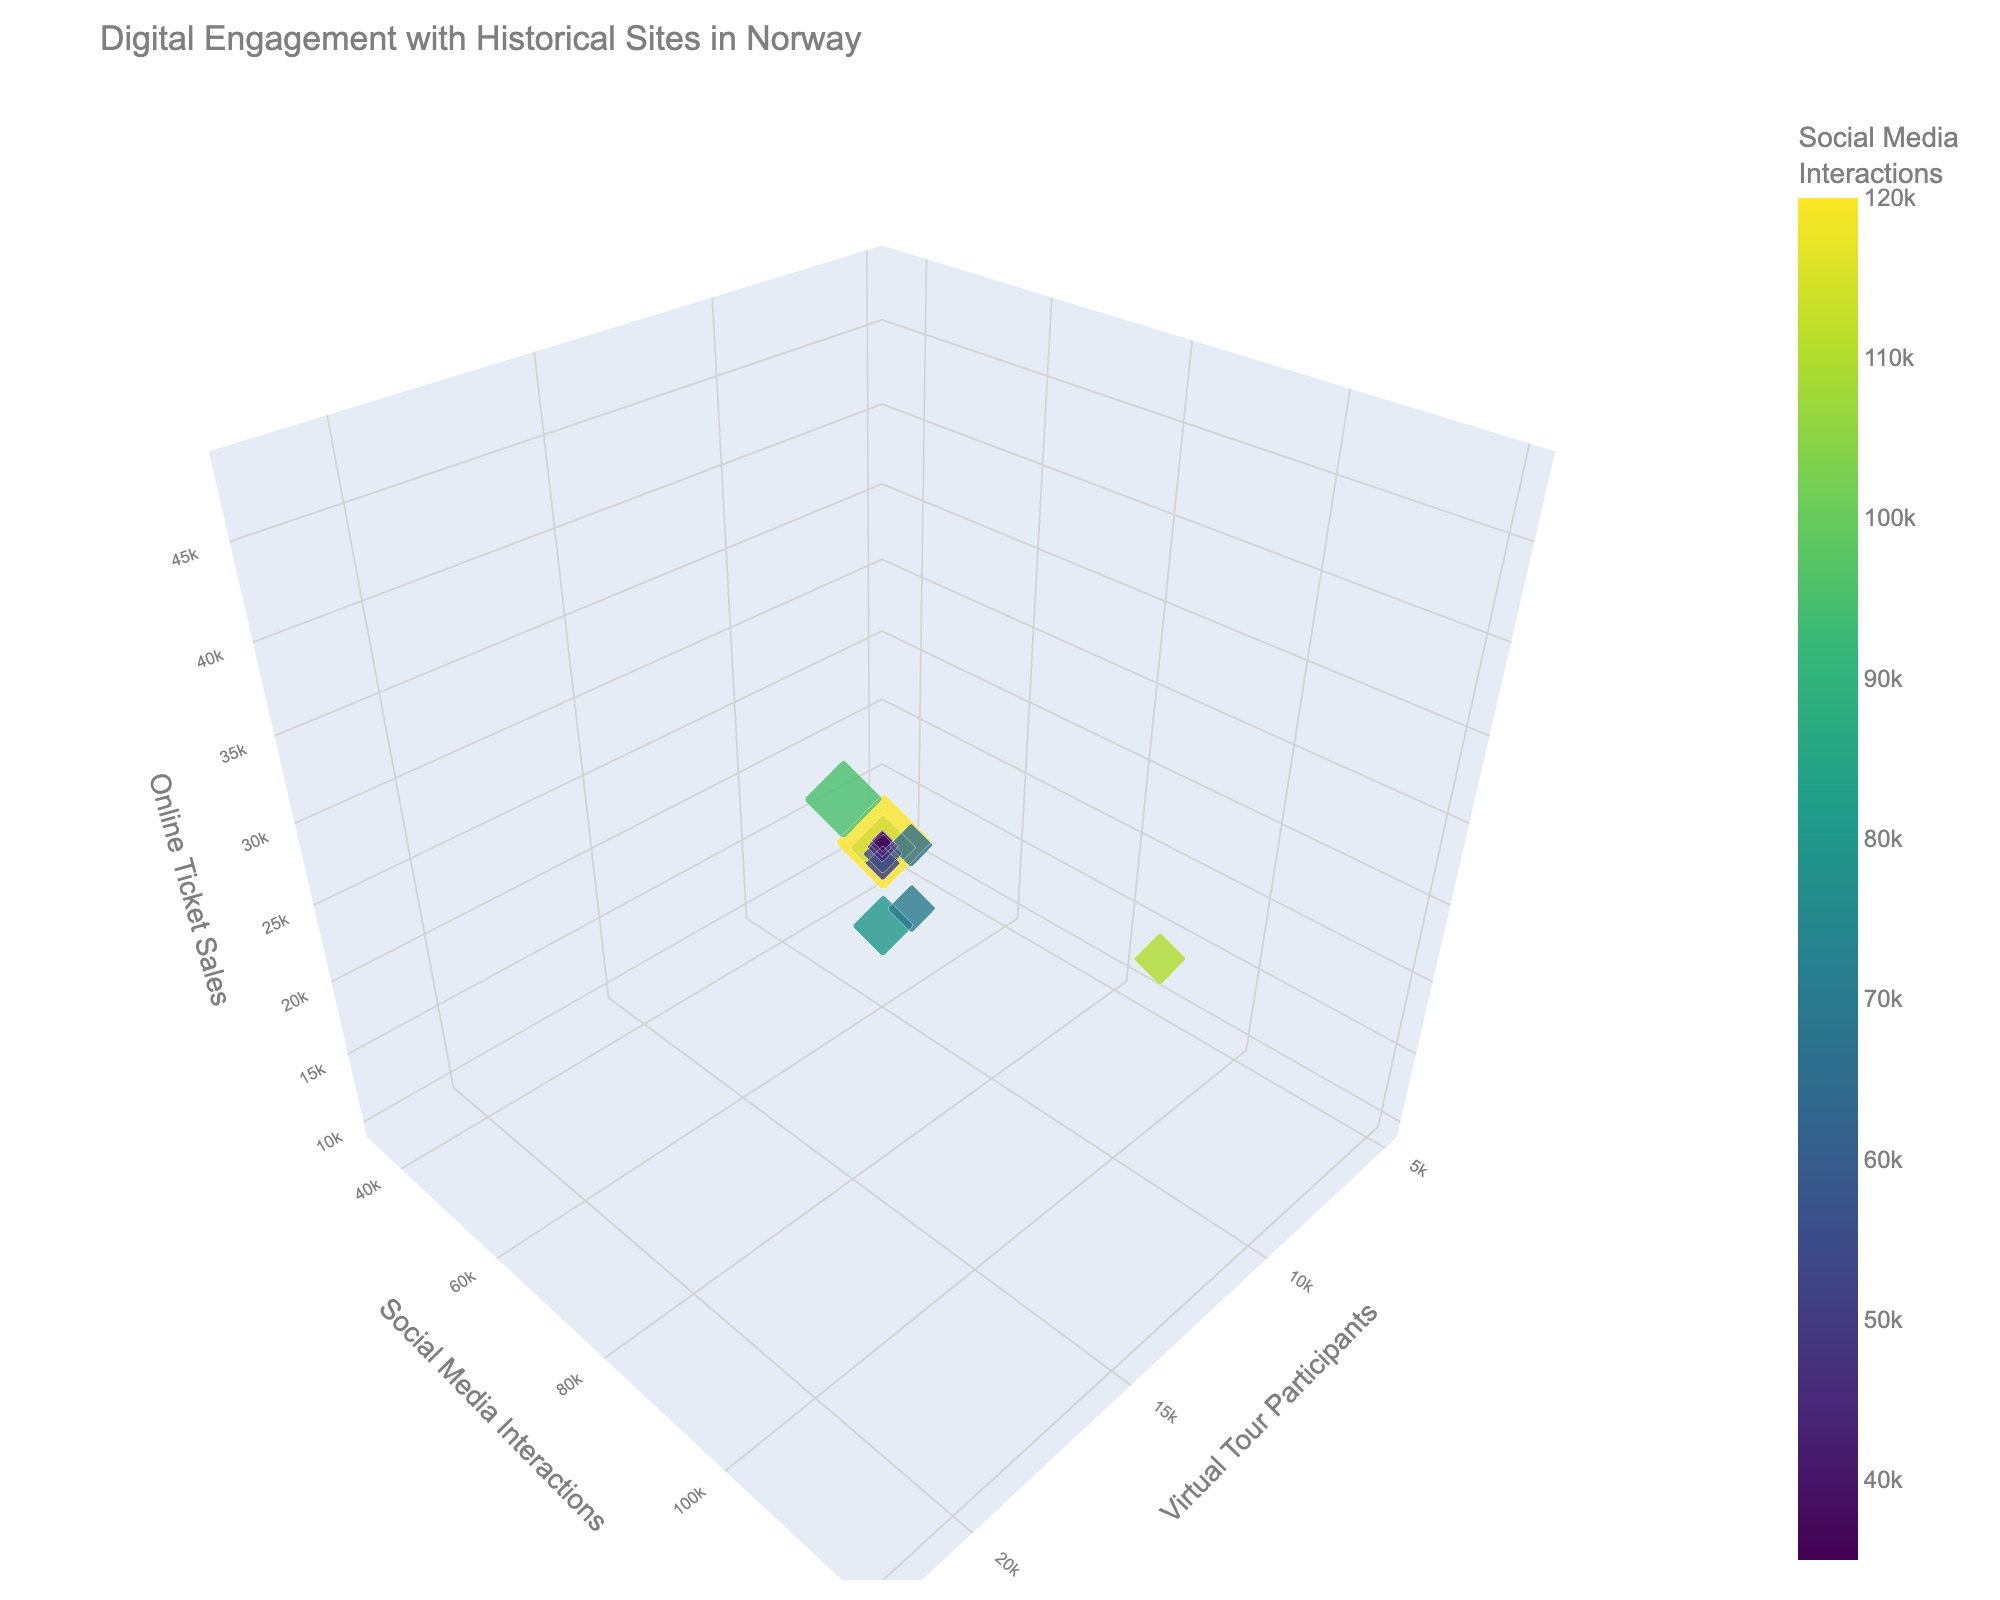How many historical sites are represented in the figure? To count the number of historical sites, look at the number of unique data points in the chart. Each bubble represents a historical site.
Answer: 12 What is the title of the chart? Look at the top of the chart where the title is usually placed.
Answer: Digital Engagement with Historical Sites in Norway Which site has the highest number of social media interactions? Identify the bubble that is positioned farthest along the y-axis with social media interactions.
Answer: Viking Ship Museum What is the color scale used to represent social media interactions? Observe the color gradient of the bubbles and associated color bar on the right.
Answer: Viridis Which site has the largest bubble, and what does that represent? Locate the largest bubble and refer to the associated site and what the larger size indicates.
Answer: Viking Ship Museum, representing the highest number of virtual tour participants Which site has the fewest online ticket sales? Look for the bubble positioned lowest along the z-axis, which indicates online ticket sales.
Answer: Steinvikholm Castle What are the average online ticket sales for all sites? Sum the z-values for online ticket sales for all 12 sites and then divide by 12 to get the average. (32000 + 48000 + 40000 + 28000 + 15000 + 22000 + 12000 + 18000 + 25000 + 14000 + 20000 + 10000) / 12 = 314083 / 12
Answer: 26166.67 Which site has approximately the same amount of virtual tour participants as Nidaros Cathedral but fewer online ticket sales? Compare the x-values of sites close to 18000 (Nidaros Cathedral's participants) and find the corresponding z-values for online ticket sales to see if they're smaller.
Answer: Lofotr Viking Museum Is there any correlation between the number of virtual tour participants and social media interactions? Observe if there is a pattern in the placement of the bubbles along the x and y axes to interpret correlation.
Answer: Positive correlation (more participants seem to align with more interactions) What site has higher online ticket sales: Håkon's Hall or Oscarsborg Fortress? Compare the z-axis values (online ticket sales) for the bubbles representing these two sites.
Answer: Oscarsborg Fortress 